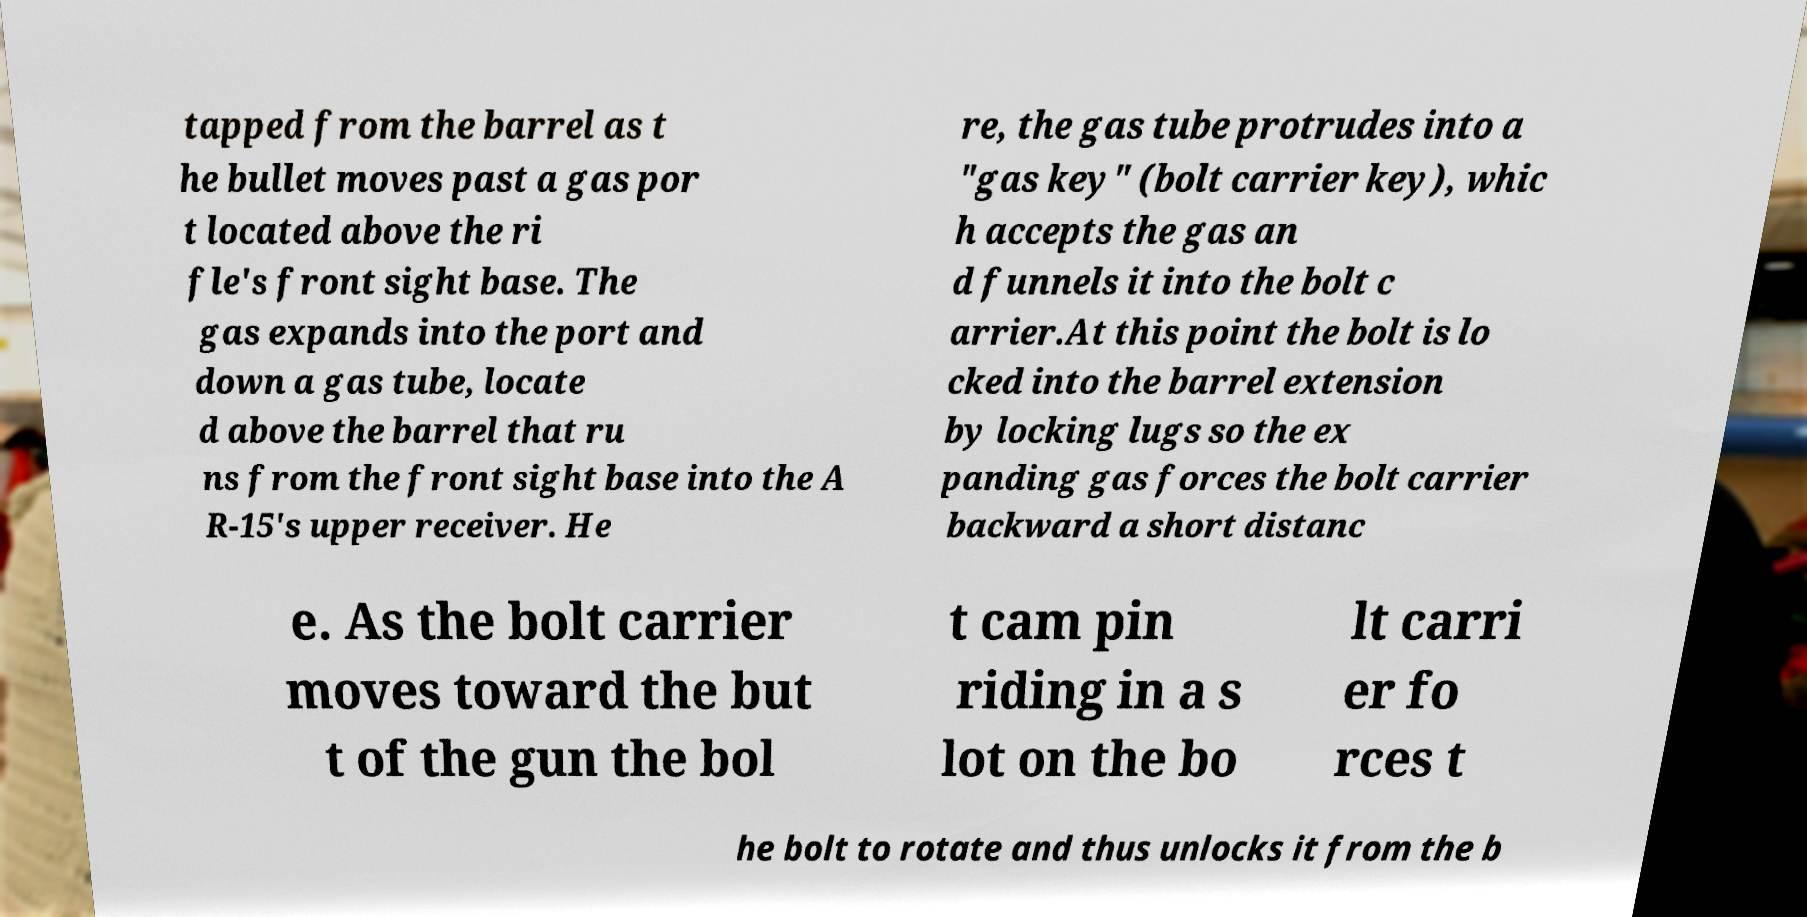Please identify and transcribe the text found in this image. tapped from the barrel as t he bullet moves past a gas por t located above the ri fle's front sight base. The gas expands into the port and down a gas tube, locate d above the barrel that ru ns from the front sight base into the A R-15's upper receiver. He re, the gas tube protrudes into a "gas key" (bolt carrier key), whic h accepts the gas an d funnels it into the bolt c arrier.At this point the bolt is lo cked into the barrel extension by locking lugs so the ex panding gas forces the bolt carrier backward a short distanc e. As the bolt carrier moves toward the but t of the gun the bol t cam pin riding in a s lot on the bo lt carri er fo rces t he bolt to rotate and thus unlocks it from the b 